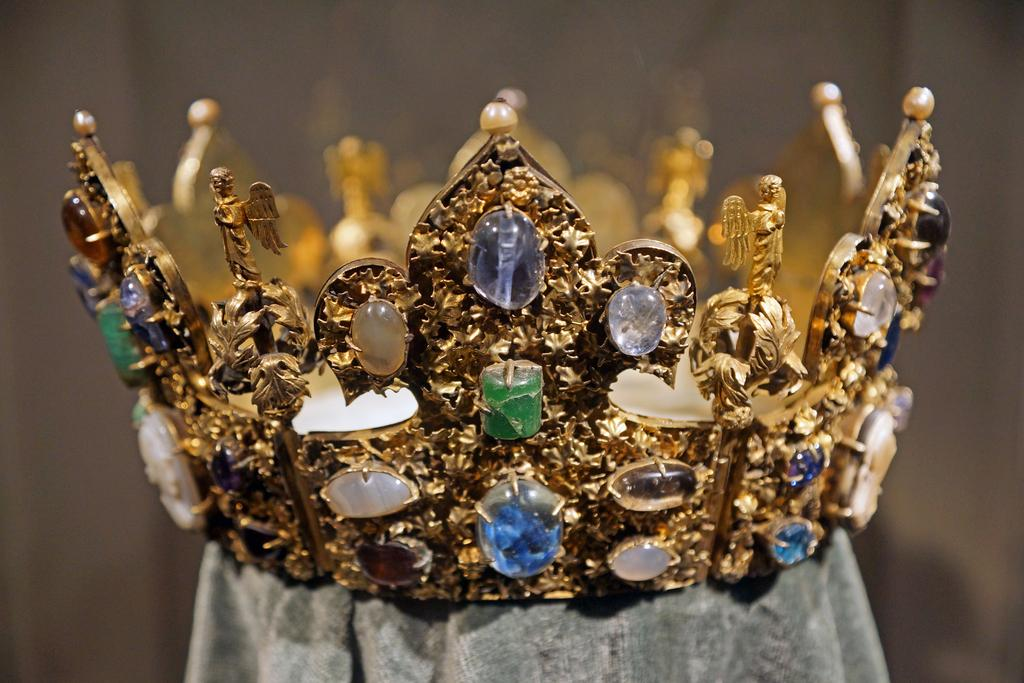What is the main object in the image? There is a crown in the image. What type of decorations are on the crown? The crown has pearls, diamonds, and stones in it. What is the color of the crown? The crown is gold in color. What is the crown placed on? The crown is placed on a white substance. What type of beast is present in the image? There is no beast present in the image; it features a crown with various decorations. Can you tell me how many stomachs the crown has in the image? The crown is an inanimate object and does not have any stomachs. 